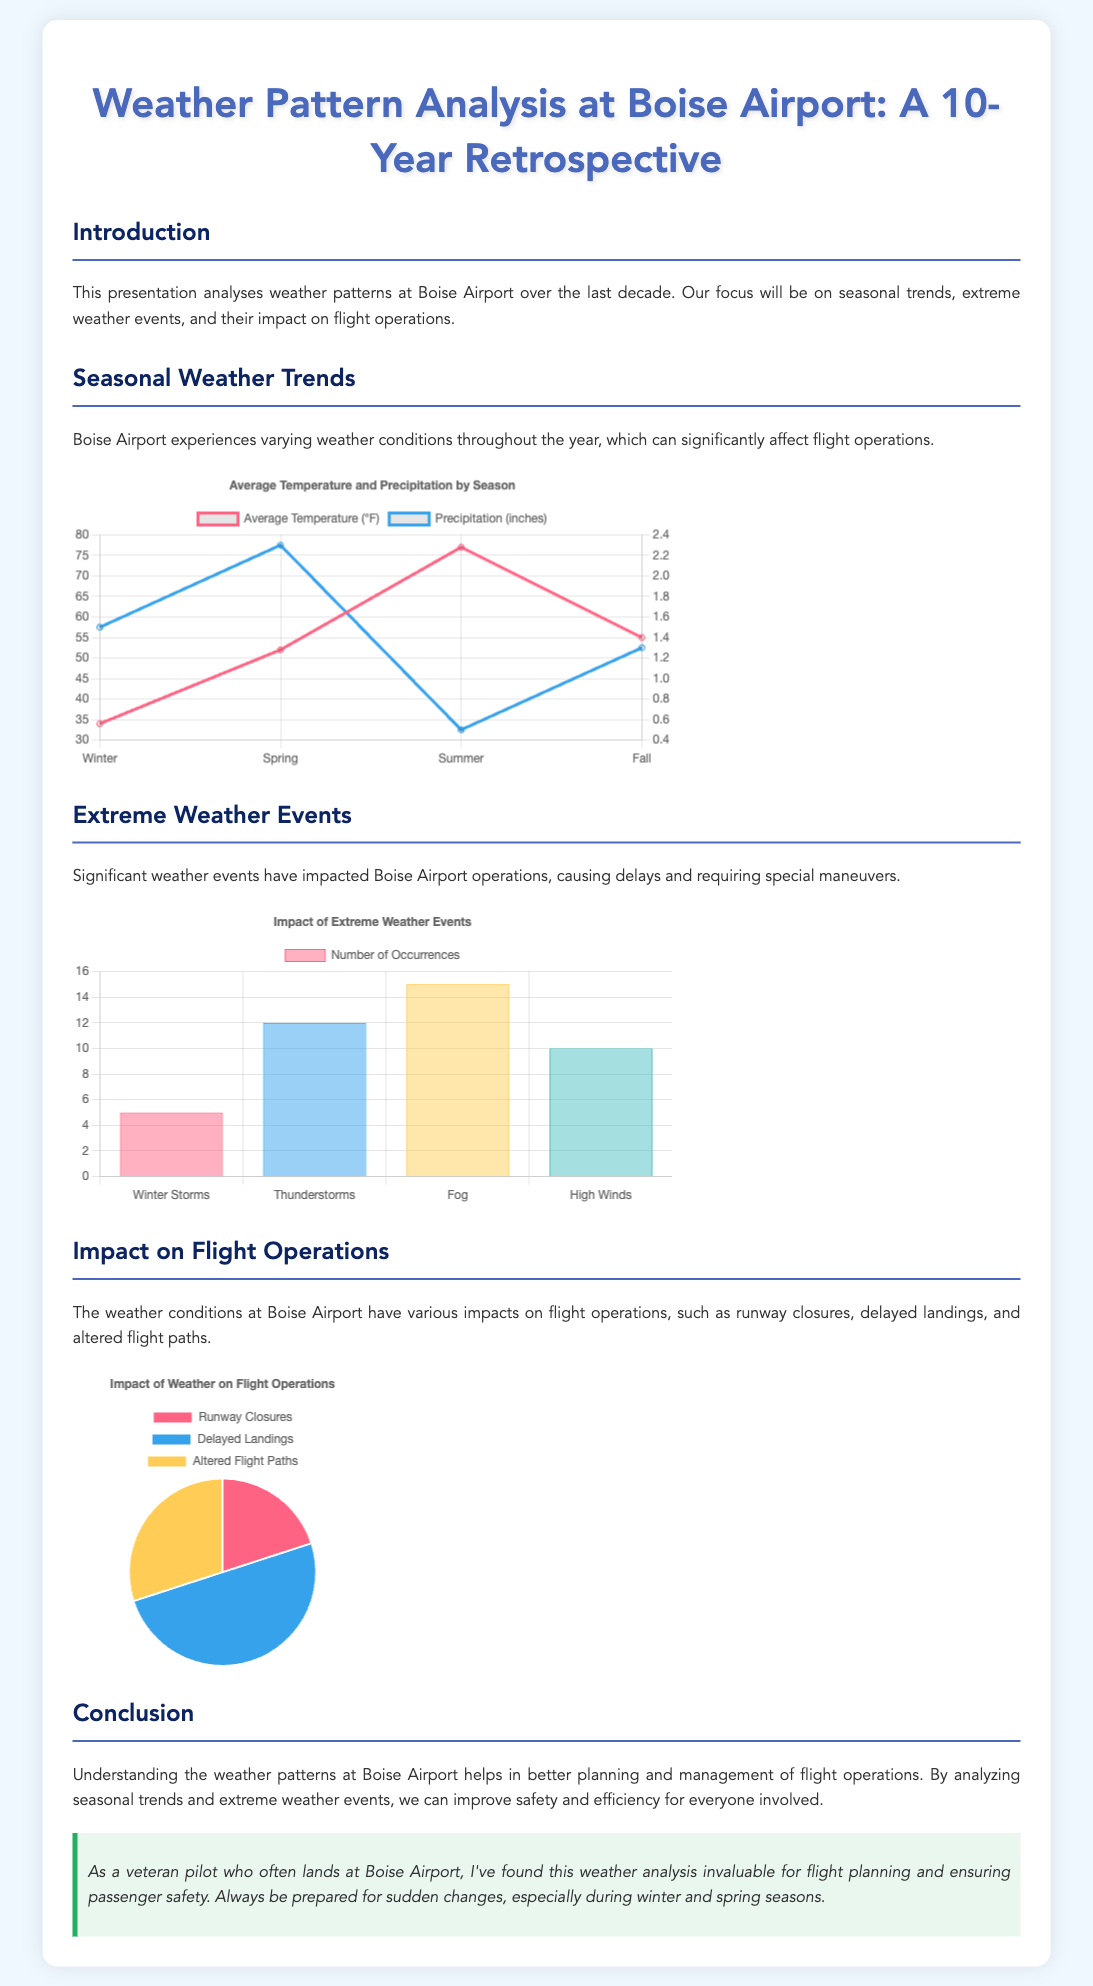What is the average temperature in summer? The chart displays an average temperature of 77°F for summer at Boise Airport.
Answer: 77°F How many occurrences of thunderstorms were recorded? According to the extreme weather events chart, there were 12 occurrences of thunderstorms noted.
Answer: 12 What type of chart is used for seasonal weather trends? The seasonal weather trends section utilizes a line chart to represent temperature and precipitation data.
Answer: Line chart What is the percentage of delayed landings impacting flight operations? The pie chart indicates that delayed landings represent 50% of the impacts on flight operations at Boise Airport.
Answer: 50% In which season is the precipitation the highest? The data suggests that spring has the highest recorded precipitation at 2.3 inches.
Answer: Spring How many extreme weather events categorize as fog? The extreme weather events chart lists fog occurrences at 15 events.
Answer: 15 What are the three impacts of weather on flight operations? The document states that runway closures, delayed landings, and altered flight paths are the key impacts.
Answer: Runway closures, delayed landings, altered flight paths What is the title of the presentation? The title of the presentation clearly states "Weather Pattern Analysis at Boise Airport: A 10-Year Retrospective."
Answer: Weather Pattern Analysis at Boise Airport: A 10-Year Retrospective 